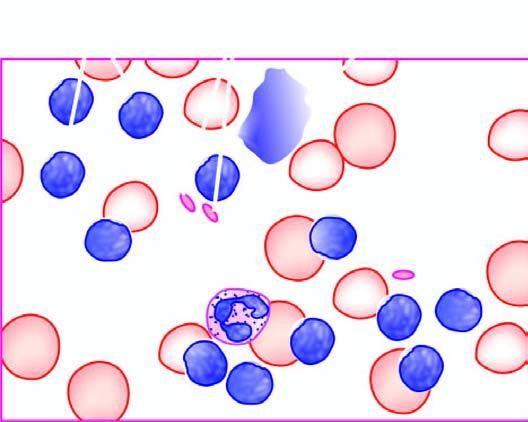s some excess of mature and small differentiated lymphocytes degenerate forms appearing as bare smudged nuclei?
Answer the question using a single word or phrase. Yes 